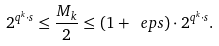Convert formula to latex. <formula><loc_0><loc_0><loc_500><loc_500>2 ^ { q ^ { k } \cdot s } \leq \frac { M _ { k } } 2 \leq ( 1 + \ e p s ) \cdot 2 ^ { q ^ { k } \cdot s } .</formula> 